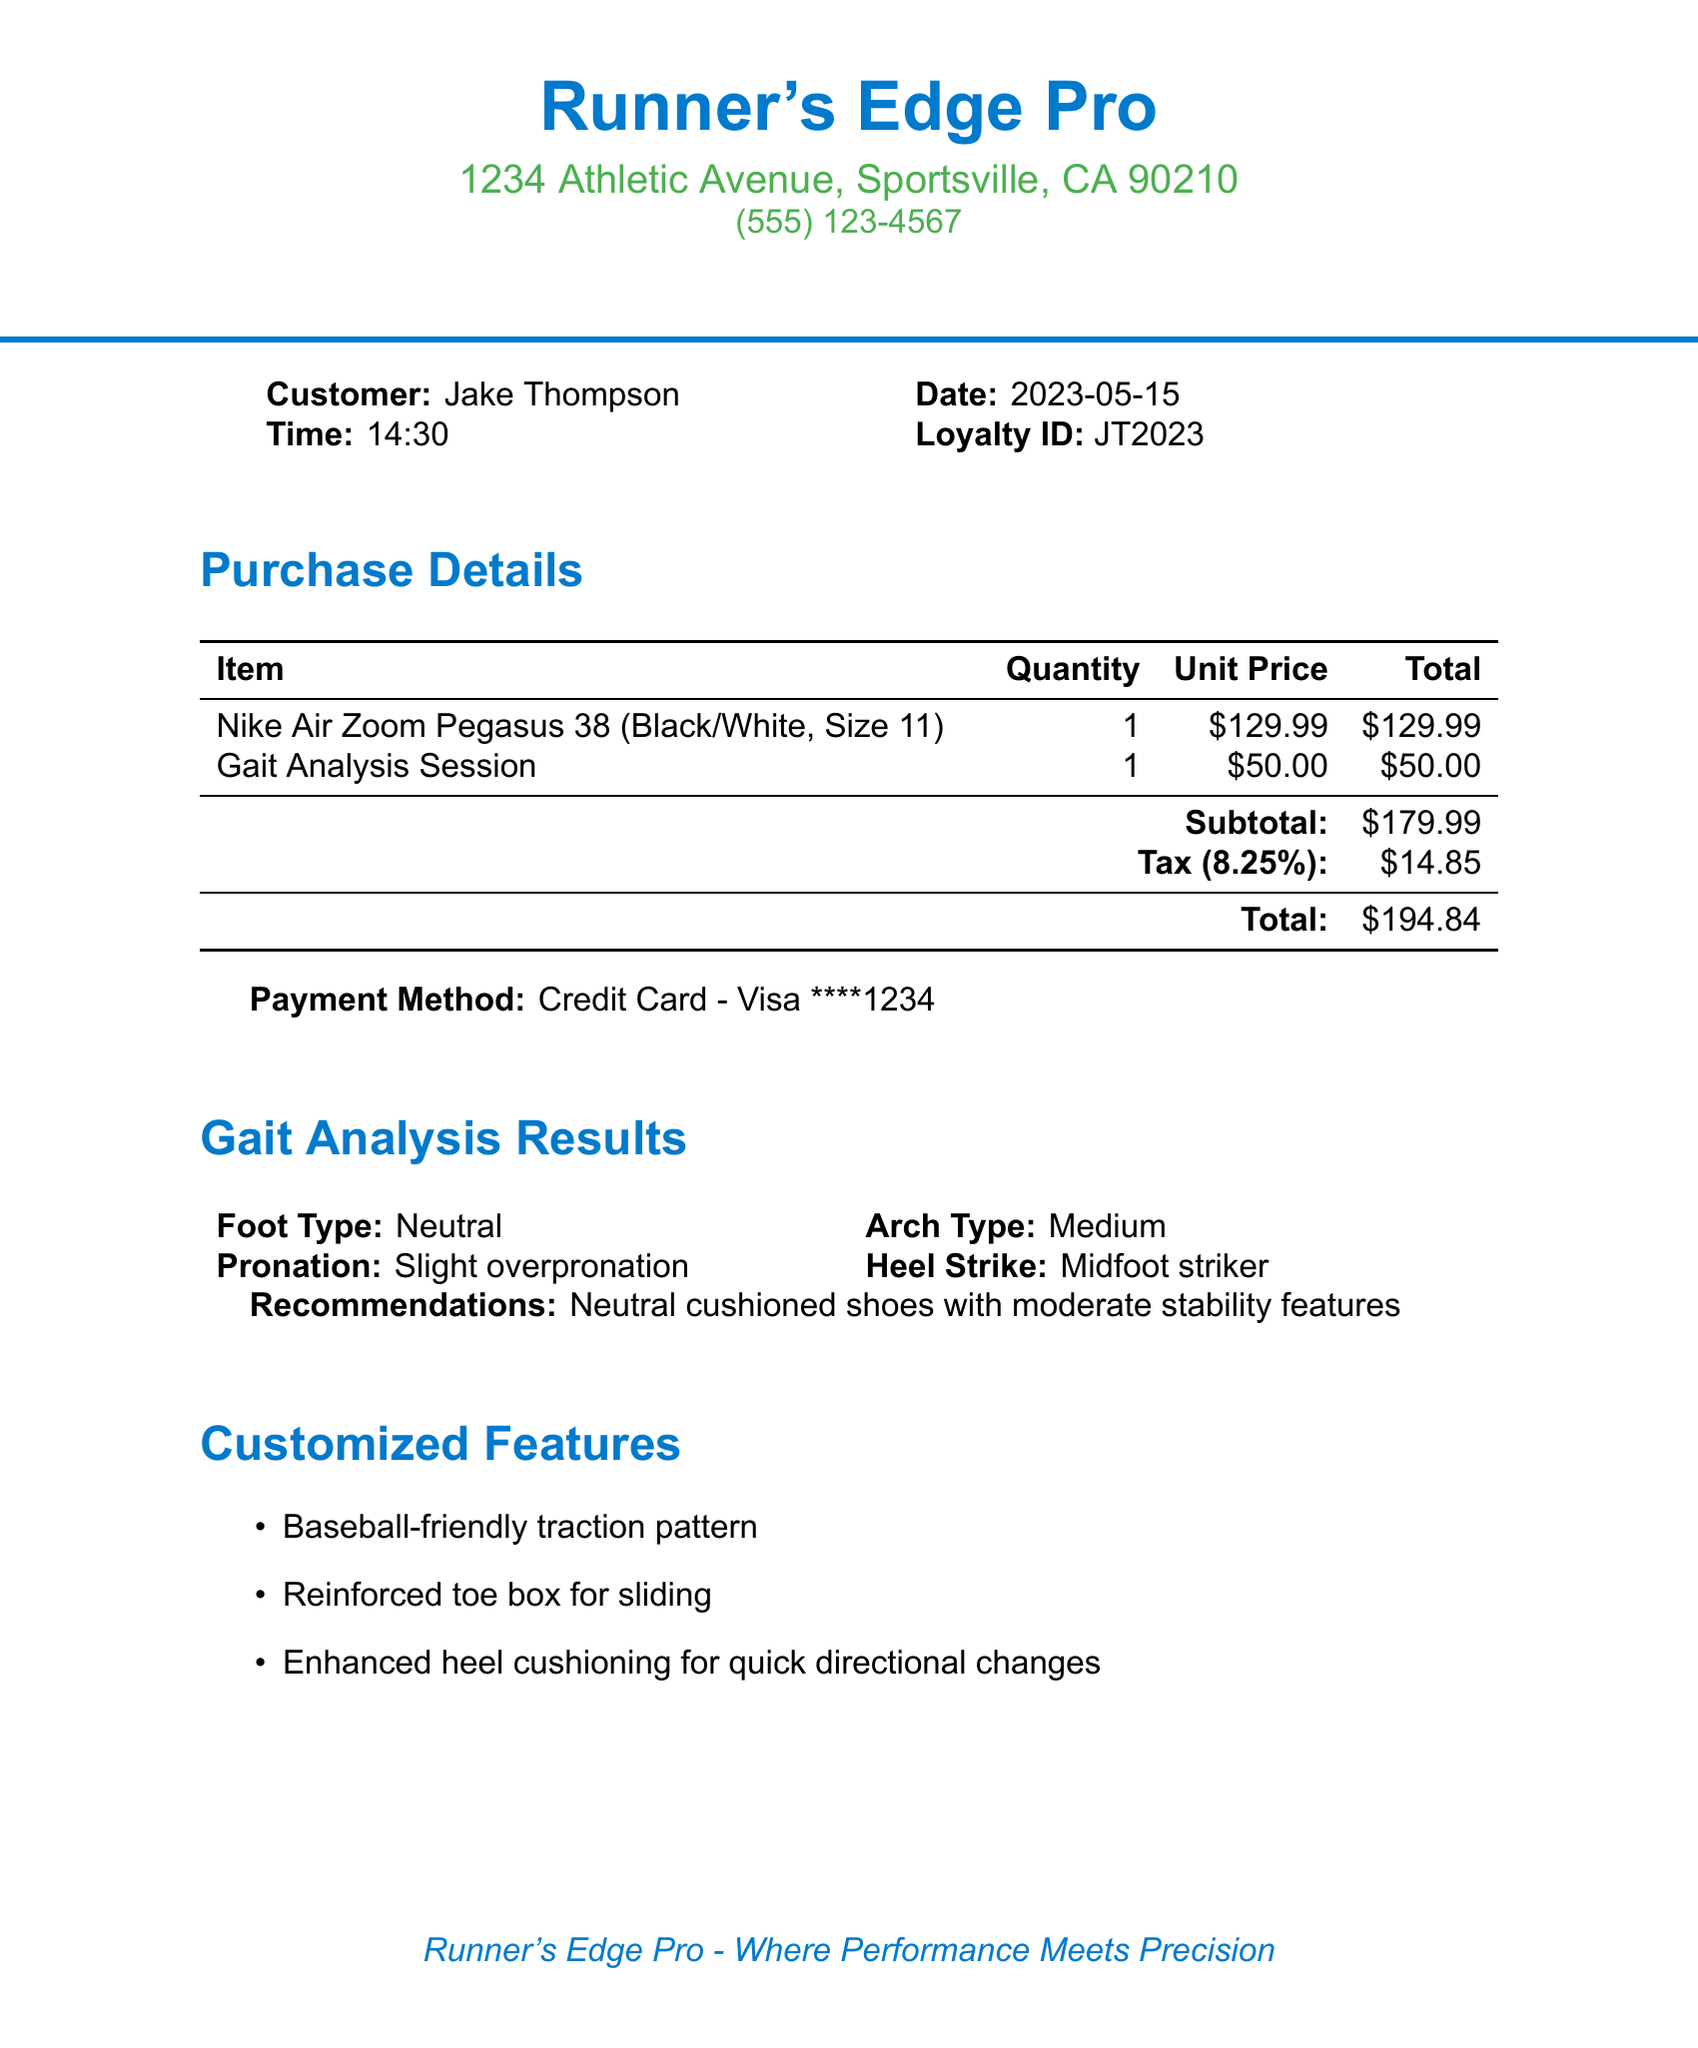What is the store name? The store name is presented prominently at the top of the document.
Answer: Runner's Edge Pro What is the date of the purchase? The date is clearly mentioned in the customer information section of the document.
Answer: 2023-05-15 How much did the Gait Analysis Session cost? The price of the Gait Analysis Session is listed under the purchase details section.
Answer: 50.00 What type of foot was indicated in the gait analysis results? The foot type is explicitly stated in the gait analysis results section.
Answer: Neutral What are the total loyalty points earned? The document states the points earned in the loyalty program section.
Answer: 195 What is the next reward for the loyalty program? The next reward is mentioned in the loyalty program details.
Answer: Free pair of performance socks at 1500 points How many items were purchased? The number of items can be determined by counting the entries in the purchase details.
Answer: 2 What additional feature is listed for durability? The customized features section includes various attributes, including durability.
Answer: Reinforced toe box for sliding What time was the purchase made? The purchase time is noted in the customer details at the top of the document.
Answer: 14:30 